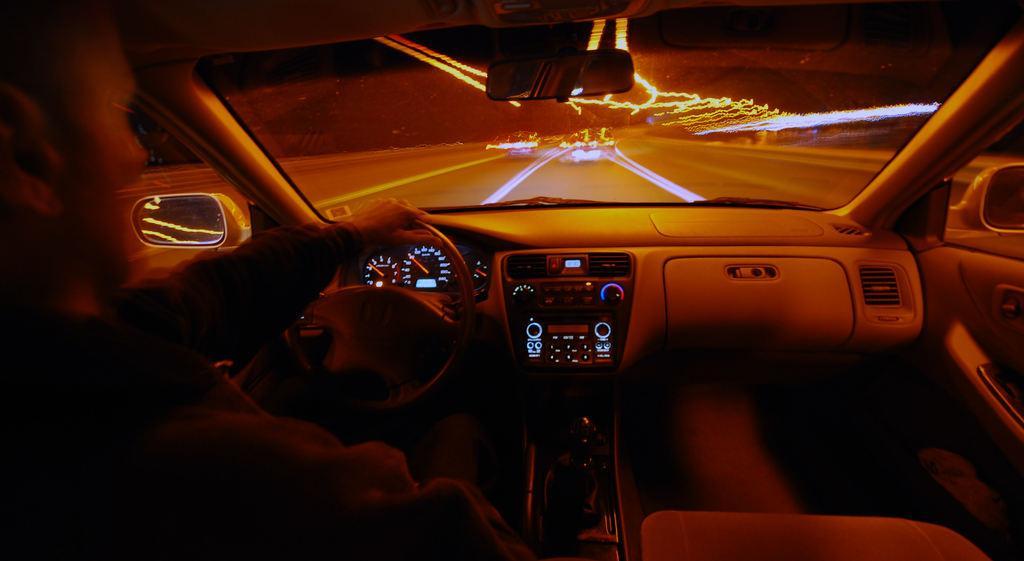Please provide a concise description of this image. This picture is taken inside a vehicle. There is a person holding the steering. Few vehicles are on the road. Behind the steering there is a meter indicator. 